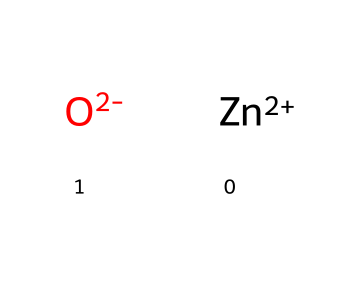what is the molecular formula of this chemical? The chemical is represented as [Zn+2].[O-2], indicating it is composed of one zinc atom (Zn) noted by the 'Zn+2' and one oxygen atom (O) indicated by the 'O-2'. Therefore, the molecular formula is ZnO.
Answer: ZnO how many atoms are present in this chemical? The structure shows one zinc atom and one oxygen atom, totaling two atoms in this chemical representation.
Answer: 2 what type of bond exists between the zinc and oxygen in this molecule? The SMILES notation suggests that zinc (cation) and oxygen (anion) form an ionic bond, due to the presence of opposite charges indicated by ‘Zn+2’ and ‘O-2’.
Answer: ionic what are the common uses of this chemical in cosmetics? Zinc oxide is commonly used in cosmetics for its properties such as UV protection and its function as a skin protectant, especially in sunscreen formulations for outdoor activities.
Answer: sunscreen how does the presence of zinc oxide benefit outdoor athletes? Zinc oxide helps outdoor athletes by providing broad-spectrum UV protection against harmful sun rays and reducing the risk of skin damage while they are engaged in sports outdoors.
Answer: UV protection why is zinc oxide considered safe for topical application? Zinc oxide is a mineral compound that is non-toxic, does not penetrate the skin, and is well-tolerated, making it safe for topical application in cosmetics, including sunscreens.
Answer: non-toxic 